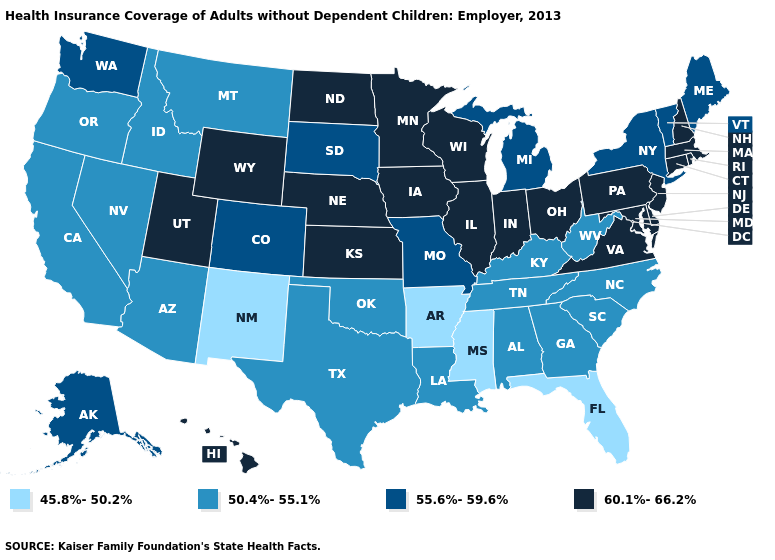What is the highest value in states that border Minnesota?
Give a very brief answer. 60.1%-66.2%. How many symbols are there in the legend?
Concise answer only. 4. What is the value of New Mexico?
Write a very short answer. 45.8%-50.2%. Which states have the highest value in the USA?
Write a very short answer. Connecticut, Delaware, Hawaii, Illinois, Indiana, Iowa, Kansas, Maryland, Massachusetts, Minnesota, Nebraska, New Hampshire, New Jersey, North Dakota, Ohio, Pennsylvania, Rhode Island, Utah, Virginia, Wisconsin, Wyoming. What is the value of Oregon?
Concise answer only. 50.4%-55.1%. Is the legend a continuous bar?
Keep it brief. No. What is the lowest value in the Northeast?
Quick response, please. 55.6%-59.6%. Name the states that have a value in the range 60.1%-66.2%?
Concise answer only. Connecticut, Delaware, Hawaii, Illinois, Indiana, Iowa, Kansas, Maryland, Massachusetts, Minnesota, Nebraska, New Hampshire, New Jersey, North Dakota, Ohio, Pennsylvania, Rhode Island, Utah, Virginia, Wisconsin, Wyoming. Name the states that have a value in the range 50.4%-55.1%?
Short answer required. Alabama, Arizona, California, Georgia, Idaho, Kentucky, Louisiana, Montana, Nevada, North Carolina, Oklahoma, Oregon, South Carolina, Tennessee, Texas, West Virginia. Does Indiana have a lower value than South Carolina?
Be succinct. No. What is the value of Rhode Island?
Be succinct. 60.1%-66.2%. Does Mississippi have the lowest value in the USA?
Concise answer only. Yes. Does Illinois have the highest value in the USA?
Answer briefly. Yes. Is the legend a continuous bar?
Be succinct. No. Which states have the lowest value in the USA?
Answer briefly. Arkansas, Florida, Mississippi, New Mexico. 